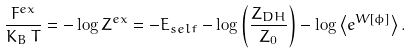Convert formula to latex. <formula><loc_0><loc_0><loc_500><loc_500>\frac { F ^ { e x } } { K _ { B } \, T } = - \log Z ^ { e x } = - E _ { s e l f } - \log \left ( \frac { Z _ { D H } } { Z _ { 0 } } \right ) - \log \left \langle e ^ { W [ \phi ] } \right \rangle .</formula> 